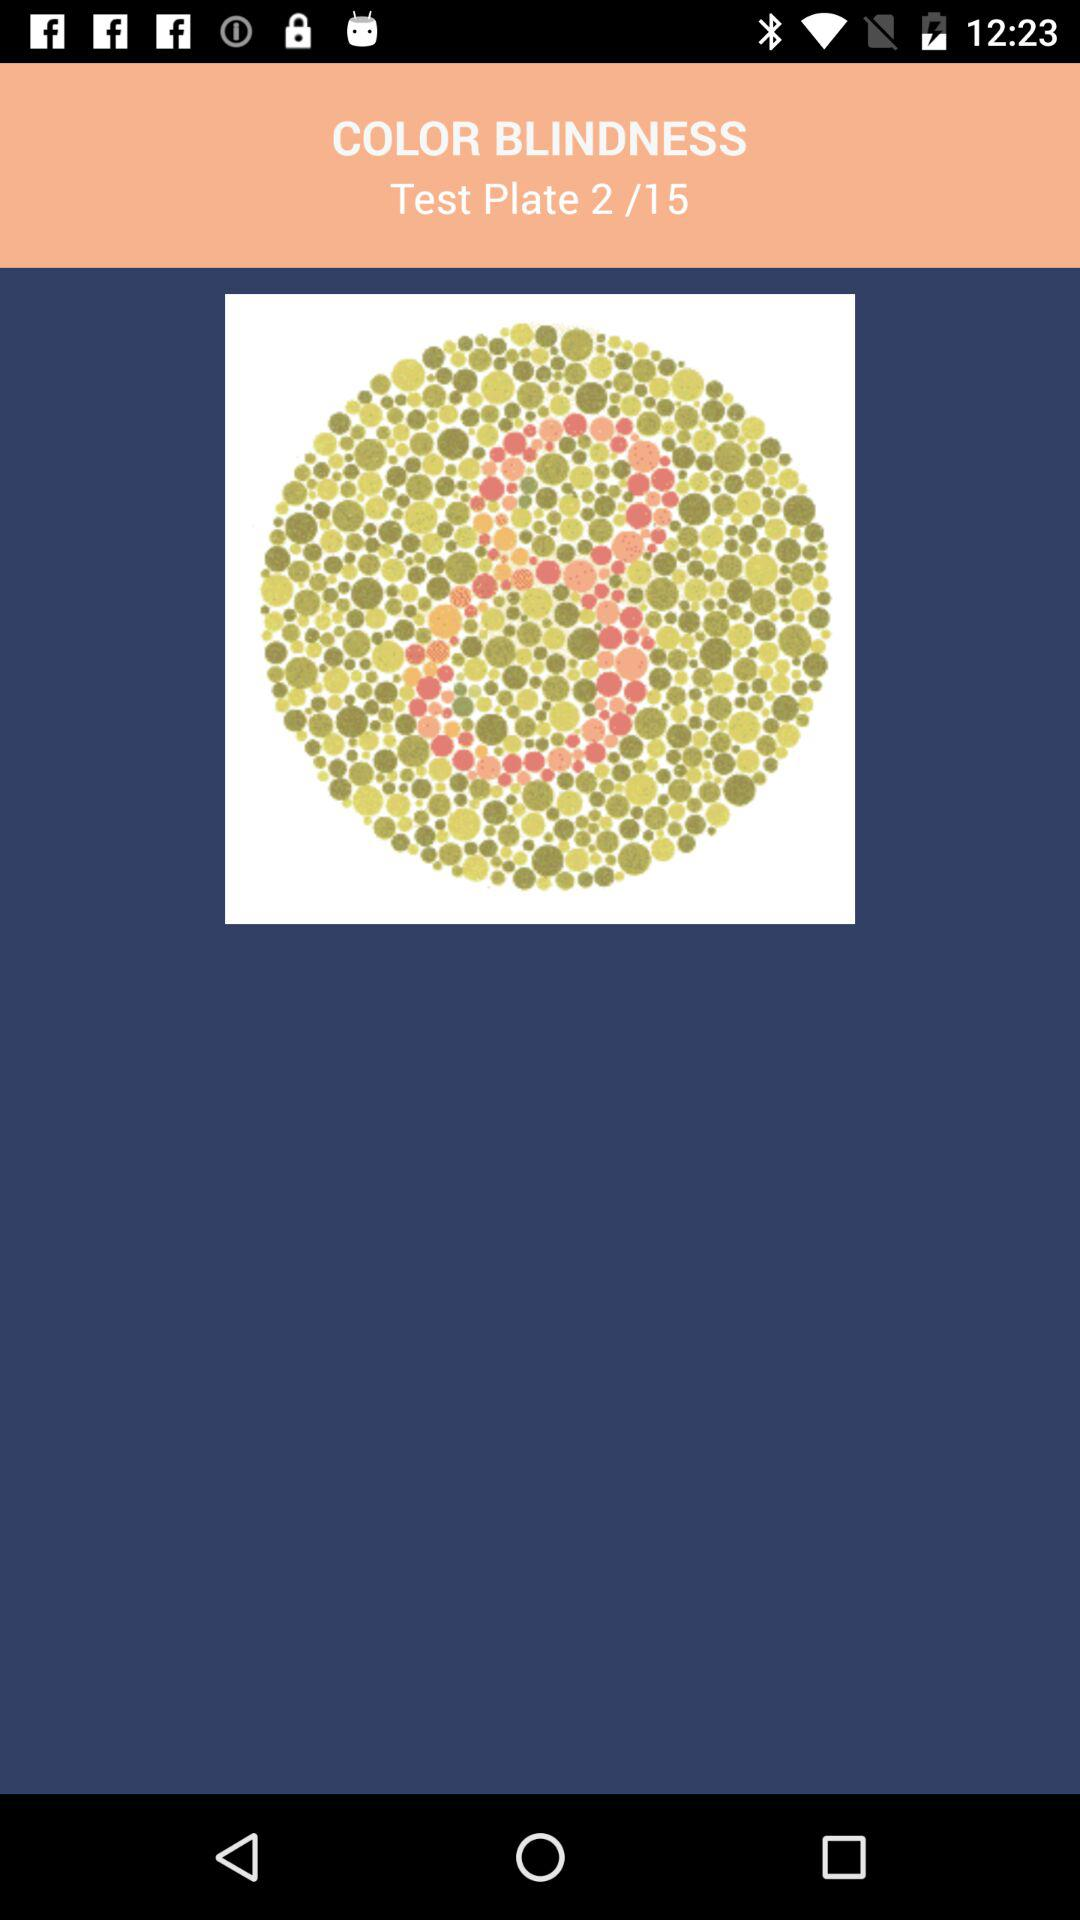Which number is shown on the test plate? The shown number is 8. 